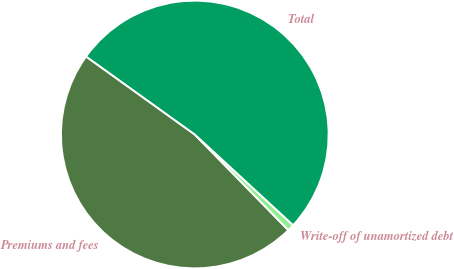Convert chart to OTSL. <chart><loc_0><loc_0><loc_500><loc_500><pie_chart><fcel>Premiums and fees<fcel>Write-off of unamortized debt<fcel>Total<nl><fcel>47.23%<fcel>0.82%<fcel>51.95%<nl></chart> 